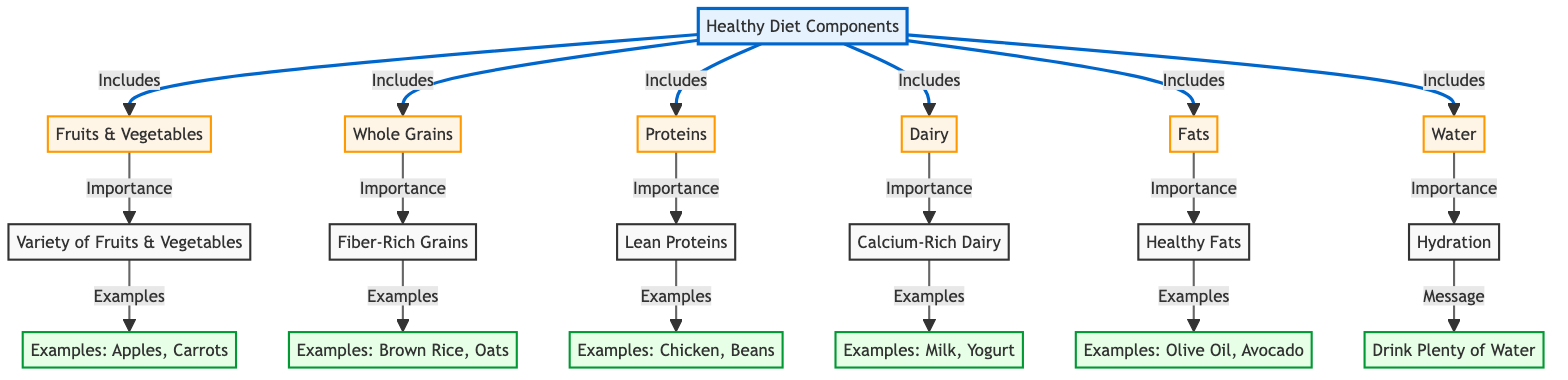What are the main components of a healthy diet for school-aged children? The diagram lists six main components that are part of a healthy diet: Fruits & Vegetables, Whole Grains, Proteins, Dairy, Fats, and Water. These components are connected directly to the main node titled "Healthy Diet Components."
Answer: Fruits & Vegetables, Whole Grains, Proteins, Dairy, Fats, Water How many sub-nodes are there under the main node? The main node "Healthy Diet Components" has six sub-nodes that represent different components of a healthy diet. Counting them gives us a total of six sub-nodes.
Answer: 6 What examples are given for fruits and vegetables? The diagram provides two specific examples of fruits and vegetables under the sub-node "Examples" linked to "Variety of Fruits & Vegetables," which are Apples and Carrots.
Answer: Apples, Carrots Which component includes the message to "Drink Plenty of Water"? The sub-node representing Water emphasizes the importance of hydration and leads to a message about drinking plenty of water, indicating its significance in the diet.
Answer: Water How are lean proteins categorized in the diagram? Lean Proteins are categorized under the Proteins sub-node, which highlights their importance and connects to specific examples like Chicken and Beans. This illustrates how Lean Proteins fit into the larger protein category.
Answer: Proteins What is the relationship between dairy and calcium-rich sources mentioned in the diagram? The diagram establishes that Dairy includes Calcium-Rich Dairy. It specifically further ties this to examples like Milk and Yogurt, indicating the source of calcium within the dairy category.
Answer: Dairy includes Calcium-Rich Dairy Identify an example given for healthy fats in the diagram. Under the sub-node for Healthy Fats, the diagram provides examples like Olive Oil and Avocado to clarify what constitutes healthy fats. This links the general category to specific food items.
Answer: Olive Oil, Avocado What is the importance of fiber-rich grains according to the diagram? Fiber-Rich Grains are connected to the sub-node Whole Grains, highlighting their significance in the diet, supporting digestive health, and ensuring a balanced nutrient intake for children.
Answer: Importance of Whole Grains What types of protein sources are listed in the examples? The examples for proteins mentioned in the diagram include Chicken and Beans, emphasizing the variety of protein sources that contribute to a healthy diet for school-aged children.
Answer: Chicken, Beans 